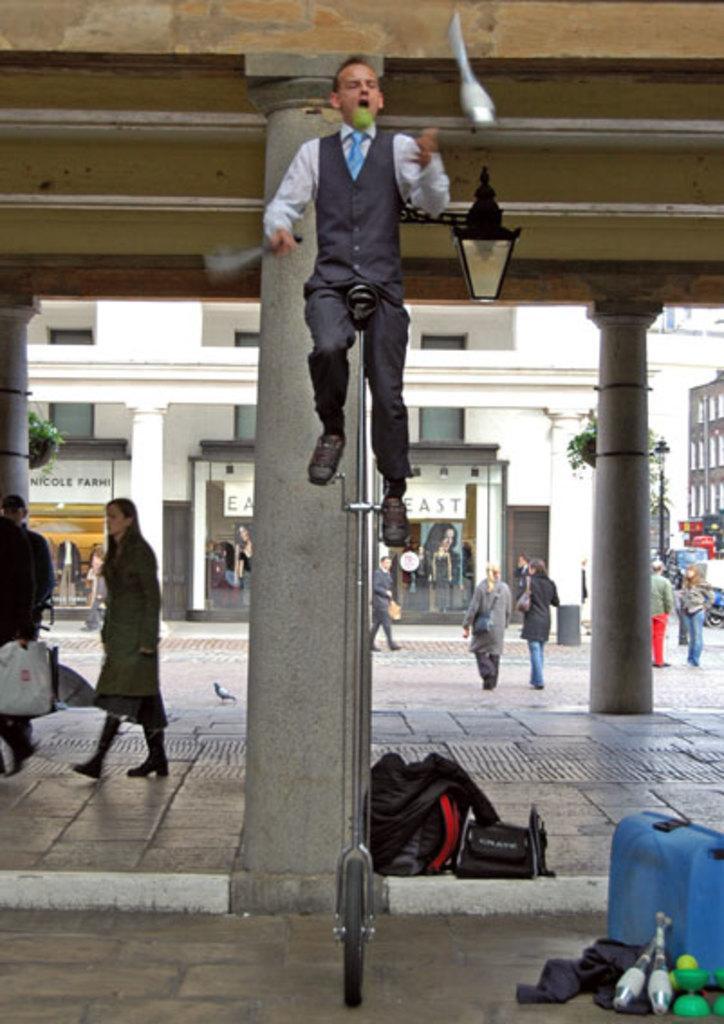In one or two sentences, can you explain what this image depicts? In this picture I can see a man seated on the unicycle and I can see few people walking in the back and I can see buildings and few bags on the ground and I can see few articles and balls on the ground and I can see couple of trees, looks like a ball in the air and I can see pole lights. 